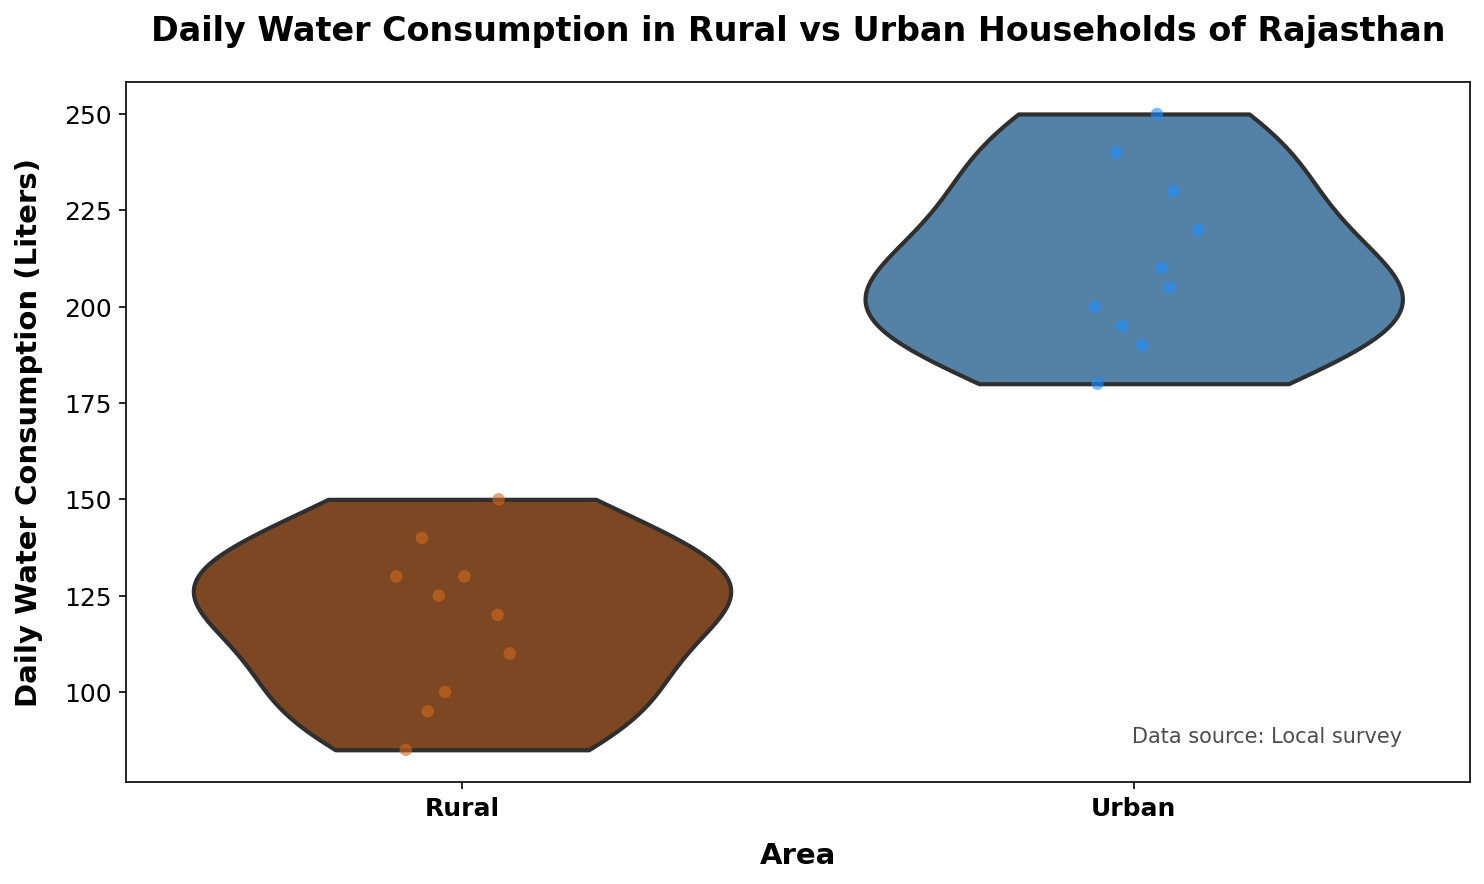What's the title of the figure? The title is at the top of the figure, it reads "Daily Water Consumption in Rural vs Urban Households of Rajasthan"
Answer: Daily Water Consumption in Rural vs Urban Households of Rajasthan What area has the highest daily water consumption? By observing the jittered points and the spread of the violins, the Urban area has higher daily water consumption values compared to the Rural area
Answer: Urban What are the units for daily water consumption on the y-axis? The y-axis label indicates that the units are Liters
Answer: Liters How many households were surveyed in each area? Count the number of jittered points for both Rural and Urban areas. There are 10 points for each, indicating 10 households surveyed in both areas
Answer: 10 Which area has a higher median daily water consumption? The median can be inferred from the thickest part of the violin. The Urban area has a visibly higher median than the Rural area
Answer: Urban What is the range of daily water consumption in the urban area? The violin plot for the Urban area shows data spread from approximately 180 to 250 liters
Answer: 180 to 250 liters What's the difference between the highest daily water consumption in urban and rural areas? The highest point in the Urban area is 250 liters, and in the Rural area, it is 150 liters, so the difference is 250 - 150 = 100 liters
Answer: 100 liters Which area shows more variability in daily water consumption? The Urban area's violin plot is wider and more spread out compared to the Rural area, indicating more variability in daily water consumption
Answer: Urban What information is included in the additional text box on the plot? The additional text box states "Data source: Local survey" placed in the bottom right corner
Answer: Data source: Local survey 